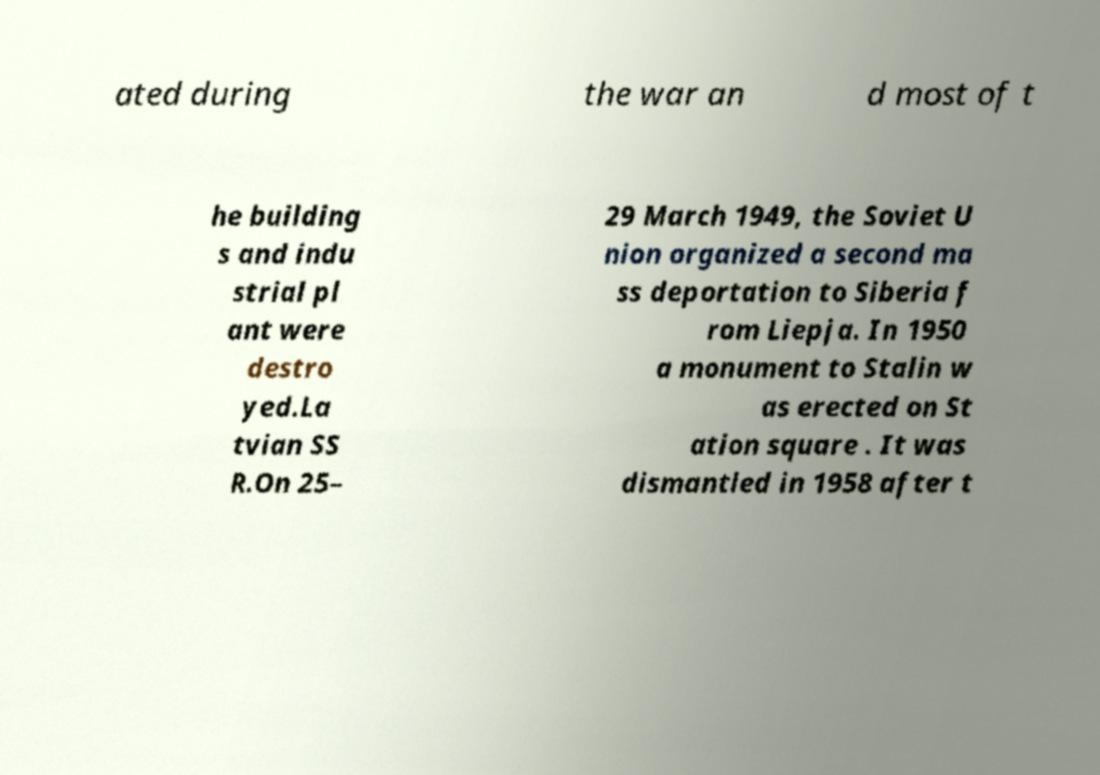Please read and relay the text visible in this image. What does it say? ated during the war an d most of t he building s and indu strial pl ant were destro yed.La tvian SS R.On 25– 29 March 1949, the Soviet U nion organized a second ma ss deportation to Siberia f rom Liepja. In 1950 a monument to Stalin w as erected on St ation square . It was dismantled in 1958 after t 